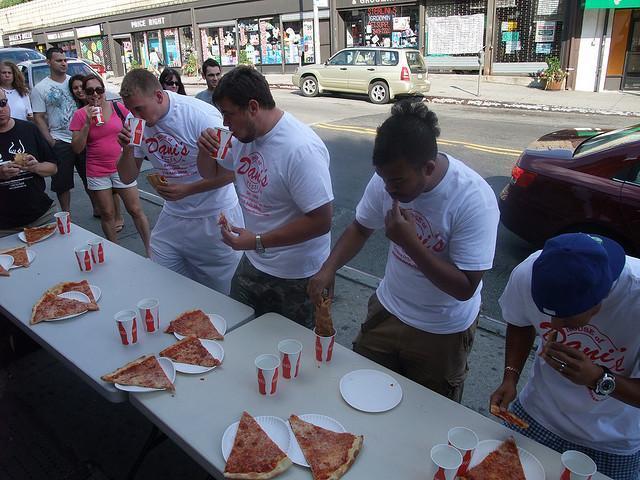How many people are participating in the eating contest?
Give a very brief answer. 4. How many dining tables can you see?
Give a very brief answer. 2. How many pizzas are there?
Give a very brief answer. 2. How many people are there?
Give a very brief answer. 7. How many cars are there?
Give a very brief answer. 2. 